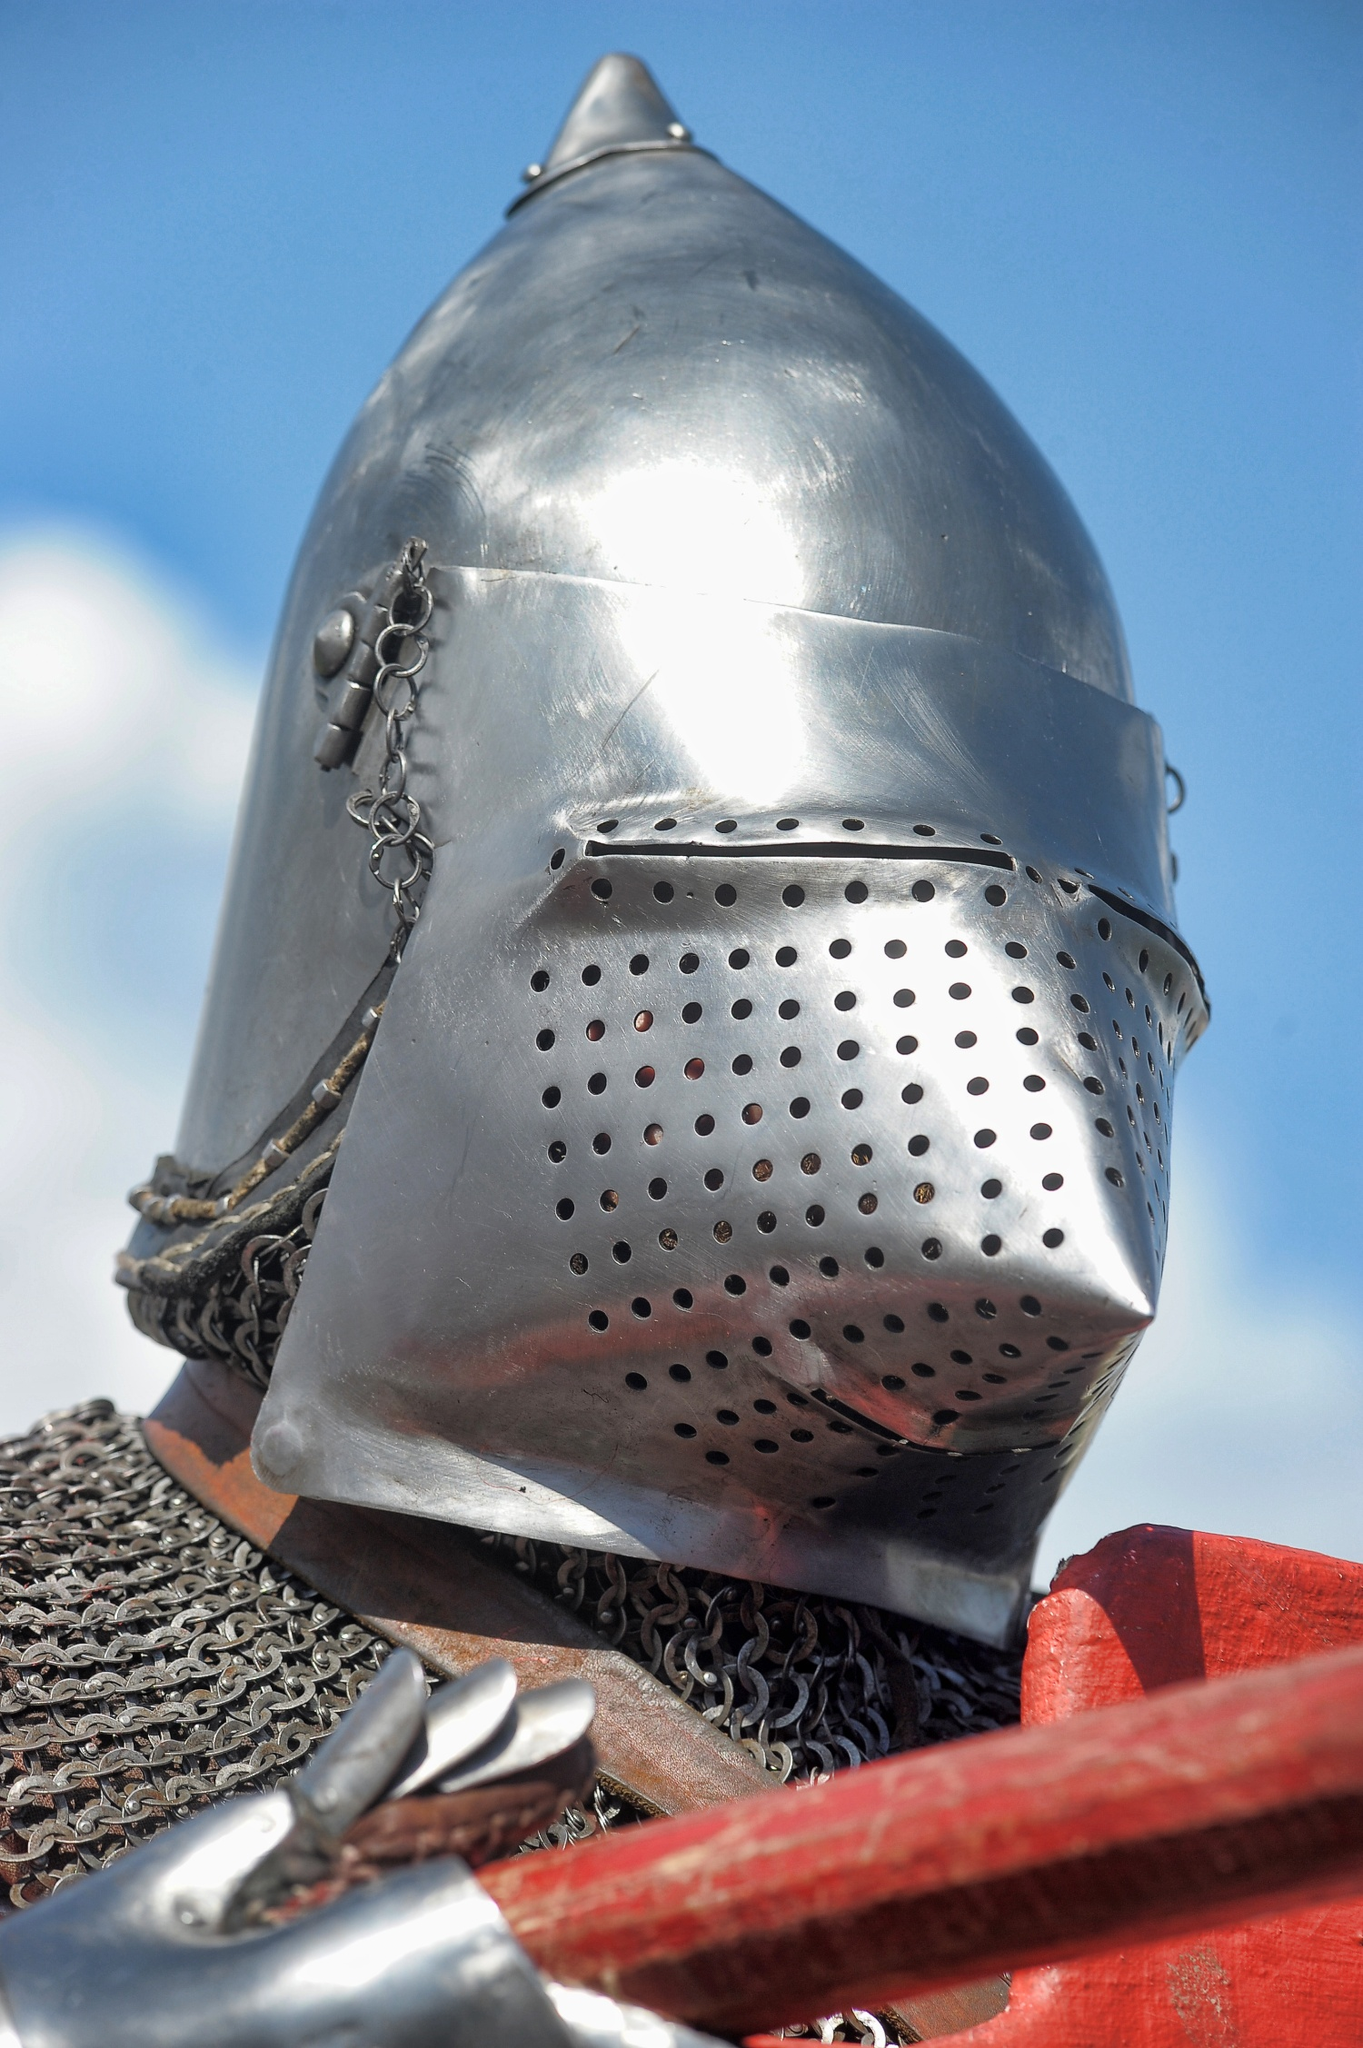What materials were used in the creation of medieval helmets like this one? Medieval helmets such as this one were typically crafted from steel or iron. Skilled blacksmiths would forge the metal using a combination of heat and hammering to shape it. The chainmail part would be made from interlinked iron or steel rings, painstakingly joined together to provide flexible protection for the neck and shoulders. 